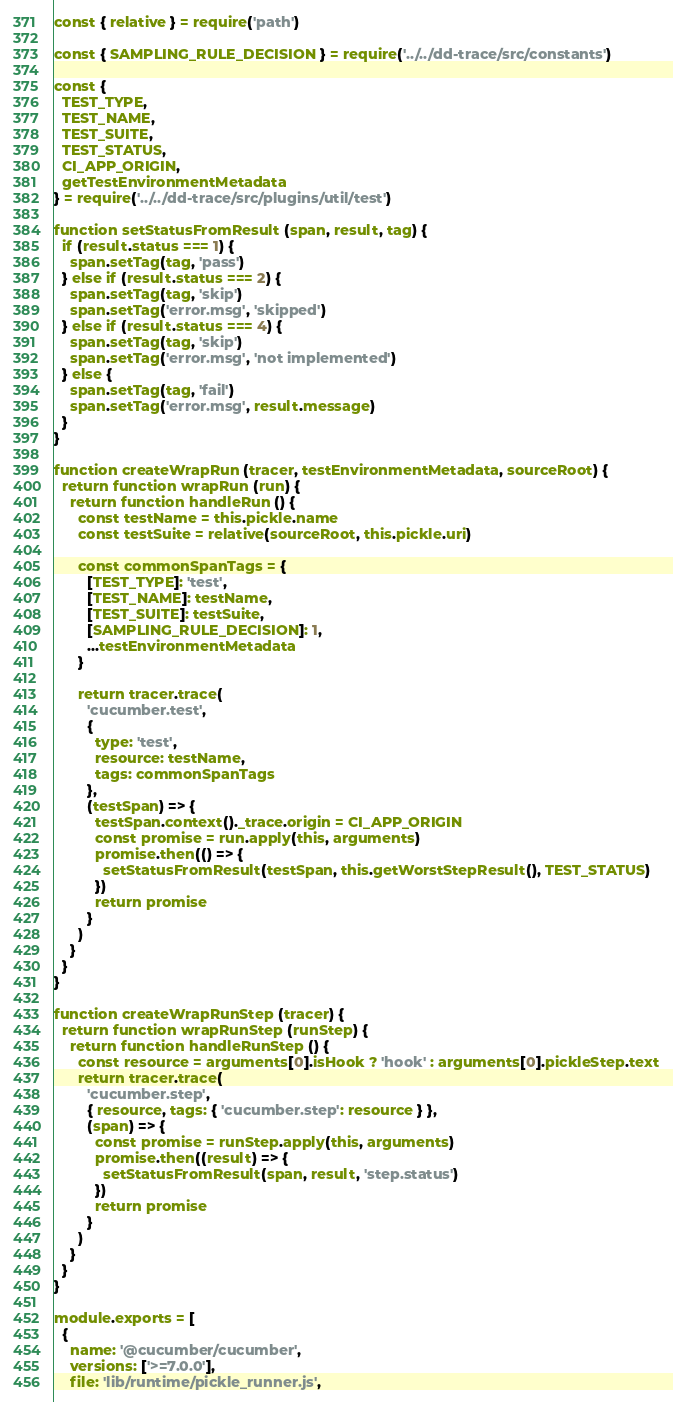<code> <loc_0><loc_0><loc_500><loc_500><_JavaScript_>const { relative } = require('path')

const { SAMPLING_RULE_DECISION } = require('../../dd-trace/src/constants')

const {
  TEST_TYPE,
  TEST_NAME,
  TEST_SUITE,
  TEST_STATUS,
  CI_APP_ORIGIN,
  getTestEnvironmentMetadata
} = require('../../dd-trace/src/plugins/util/test')

function setStatusFromResult (span, result, tag) {
  if (result.status === 1) {
    span.setTag(tag, 'pass')
  } else if (result.status === 2) {
    span.setTag(tag, 'skip')
    span.setTag('error.msg', 'skipped')
  } else if (result.status === 4) {
    span.setTag(tag, 'skip')
    span.setTag('error.msg', 'not implemented')
  } else {
    span.setTag(tag, 'fail')
    span.setTag('error.msg', result.message)
  }
}

function createWrapRun (tracer, testEnvironmentMetadata, sourceRoot) {
  return function wrapRun (run) {
    return function handleRun () {
      const testName = this.pickle.name
      const testSuite = relative(sourceRoot, this.pickle.uri)

      const commonSpanTags = {
        [TEST_TYPE]: 'test',
        [TEST_NAME]: testName,
        [TEST_SUITE]: testSuite,
        [SAMPLING_RULE_DECISION]: 1,
        ...testEnvironmentMetadata
      }

      return tracer.trace(
        'cucumber.test',
        {
          type: 'test',
          resource: testName,
          tags: commonSpanTags
        },
        (testSpan) => {
          testSpan.context()._trace.origin = CI_APP_ORIGIN
          const promise = run.apply(this, arguments)
          promise.then(() => {
            setStatusFromResult(testSpan, this.getWorstStepResult(), TEST_STATUS)
          })
          return promise
        }
      )
    }
  }
}

function createWrapRunStep (tracer) {
  return function wrapRunStep (runStep) {
    return function handleRunStep () {
      const resource = arguments[0].isHook ? 'hook' : arguments[0].pickleStep.text
      return tracer.trace(
        'cucumber.step',
        { resource, tags: { 'cucumber.step': resource } },
        (span) => {
          const promise = runStep.apply(this, arguments)
          promise.then((result) => {
            setStatusFromResult(span, result, 'step.status')
          })
          return promise
        }
      )
    }
  }
}

module.exports = [
  {
    name: '@cucumber/cucumber',
    versions: ['>=7.0.0'],
    file: 'lib/runtime/pickle_runner.js',</code> 